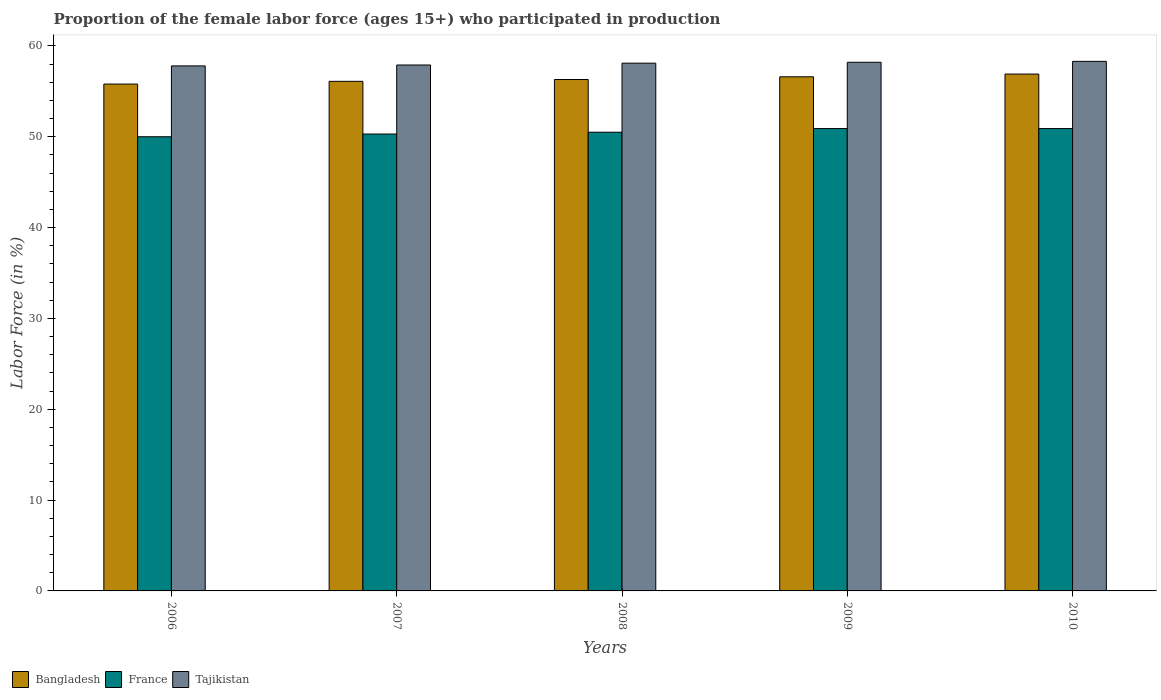How many different coloured bars are there?
Ensure brevity in your answer.  3. Are the number of bars per tick equal to the number of legend labels?
Give a very brief answer. Yes. Are the number of bars on each tick of the X-axis equal?
Your answer should be compact. Yes. How many bars are there on the 5th tick from the left?
Provide a short and direct response. 3. How many bars are there on the 5th tick from the right?
Keep it short and to the point. 3. What is the proportion of the female labor force who participated in production in France in 2009?
Provide a succinct answer. 50.9. Across all years, what is the maximum proportion of the female labor force who participated in production in Bangladesh?
Your response must be concise. 56.9. Across all years, what is the minimum proportion of the female labor force who participated in production in France?
Your answer should be very brief. 50. What is the total proportion of the female labor force who participated in production in Tajikistan in the graph?
Provide a succinct answer. 290.3. What is the difference between the proportion of the female labor force who participated in production in Tajikistan in 2006 and that in 2007?
Provide a short and direct response. -0.1. What is the difference between the proportion of the female labor force who participated in production in France in 2007 and the proportion of the female labor force who participated in production in Bangladesh in 2010?
Give a very brief answer. -6.6. What is the average proportion of the female labor force who participated in production in France per year?
Your answer should be very brief. 50.52. In the year 2007, what is the difference between the proportion of the female labor force who participated in production in France and proportion of the female labor force who participated in production in Bangladesh?
Offer a very short reply. -5.8. What is the ratio of the proportion of the female labor force who participated in production in Bangladesh in 2007 to that in 2008?
Your answer should be compact. 1. Is the difference between the proportion of the female labor force who participated in production in France in 2006 and 2008 greater than the difference between the proportion of the female labor force who participated in production in Bangladesh in 2006 and 2008?
Offer a very short reply. No. What is the difference between the highest and the lowest proportion of the female labor force who participated in production in France?
Your answer should be very brief. 0.9. In how many years, is the proportion of the female labor force who participated in production in France greater than the average proportion of the female labor force who participated in production in France taken over all years?
Offer a terse response. 2. What does the 1st bar from the right in 2008 represents?
Provide a short and direct response. Tajikistan. How many bars are there?
Keep it short and to the point. 15. How many years are there in the graph?
Keep it short and to the point. 5. What is the difference between two consecutive major ticks on the Y-axis?
Offer a very short reply. 10. Are the values on the major ticks of Y-axis written in scientific E-notation?
Offer a very short reply. No. Does the graph contain any zero values?
Keep it short and to the point. No. Where does the legend appear in the graph?
Offer a terse response. Bottom left. How are the legend labels stacked?
Provide a short and direct response. Horizontal. What is the title of the graph?
Make the answer very short. Proportion of the female labor force (ages 15+) who participated in production. What is the label or title of the X-axis?
Keep it short and to the point. Years. What is the Labor Force (in %) in Bangladesh in 2006?
Provide a succinct answer. 55.8. What is the Labor Force (in %) of Tajikistan in 2006?
Give a very brief answer. 57.8. What is the Labor Force (in %) in Bangladesh in 2007?
Ensure brevity in your answer.  56.1. What is the Labor Force (in %) in France in 2007?
Give a very brief answer. 50.3. What is the Labor Force (in %) of Tajikistan in 2007?
Your answer should be compact. 57.9. What is the Labor Force (in %) of Bangladesh in 2008?
Make the answer very short. 56.3. What is the Labor Force (in %) of France in 2008?
Offer a very short reply. 50.5. What is the Labor Force (in %) of Tajikistan in 2008?
Your answer should be compact. 58.1. What is the Labor Force (in %) in Bangladesh in 2009?
Offer a terse response. 56.6. What is the Labor Force (in %) of France in 2009?
Your answer should be very brief. 50.9. What is the Labor Force (in %) in Tajikistan in 2009?
Your answer should be compact. 58.2. What is the Labor Force (in %) in Bangladesh in 2010?
Your answer should be compact. 56.9. What is the Labor Force (in %) in France in 2010?
Keep it short and to the point. 50.9. What is the Labor Force (in %) of Tajikistan in 2010?
Ensure brevity in your answer.  58.3. Across all years, what is the maximum Labor Force (in %) of Bangladesh?
Offer a very short reply. 56.9. Across all years, what is the maximum Labor Force (in %) of France?
Keep it short and to the point. 50.9. Across all years, what is the maximum Labor Force (in %) of Tajikistan?
Your response must be concise. 58.3. Across all years, what is the minimum Labor Force (in %) of Bangladesh?
Keep it short and to the point. 55.8. Across all years, what is the minimum Labor Force (in %) in Tajikistan?
Your answer should be compact. 57.8. What is the total Labor Force (in %) of Bangladesh in the graph?
Offer a terse response. 281.7. What is the total Labor Force (in %) of France in the graph?
Your answer should be compact. 252.6. What is the total Labor Force (in %) in Tajikistan in the graph?
Ensure brevity in your answer.  290.3. What is the difference between the Labor Force (in %) of France in 2006 and that in 2008?
Keep it short and to the point. -0.5. What is the difference between the Labor Force (in %) in Tajikistan in 2006 and that in 2010?
Make the answer very short. -0.5. What is the difference between the Labor Force (in %) of Bangladesh in 2007 and that in 2008?
Offer a terse response. -0.2. What is the difference between the Labor Force (in %) of Tajikistan in 2007 and that in 2008?
Offer a very short reply. -0.2. What is the difference between the Labor Force (in %) of Bangladesh in 2007 and that in 2009?
Give a very brief answer. -0.5. What is the difference between the Labor Force (in %) of France in 2007 and that in 2009?
Provide a short and direct response. -0.6. What is the difference between the Labor Force (in %) in Bangladesh in 2007 and that in 2010?
Ensure brevity in your answer.  -0.8. What is the difference between the Labor Force (in %) of France in 2008 and that in 2009?
Offer a terse response. -0.4. What is the difference between the Labor Force (in %) of France in 2008 and that in 2010?
Offer a very short reply. -0.4. What is the difference between the Labor Force (in %) of France in 2009 and that in 2010?
Provide a succinct answer. 0. What is the difference between the Labor Force (in %) in Bangladesh in 2006 and the Labor Force (in %) in France in 2007?
Provide a short and direct response. 5.5. What is the difference between the Labor Force (in %) in Bangladesh in 2006 and the Labor Force (in %) in Tajikistan in 2007?
Provide a succinct answer. -2.1. What is the difference between the Labor Force (in %) in France in 2006 and the Labor Force (in %) in Tajikistan in 2007?
Your answer should be compact. -7.9. What is the difference between the Labor Force (in %) in Bangladesh in 2006 and the Labor Force (in %) in Tajikistan in 2008?
Provide a succinct answer. -2.3. What is the difference between the Labor Force (in %) in Bangladesh in 2006 and the Labor Force (in %) in France in 2009?
Make the answer very short. 4.9. What is the difference between the Labor Force (in %) of Bangladesh in 2006 and the Labor Force (in %) of Tajikistan in 2009?
Offer a very short reply. -2.4. What is the difference between the Labor Force (in %) in France in 2006 and the Labor Force (in %) in Tajikistan in 2009?
Give a very brief answer. -8.2. What is the difference between the Labor Force (in %) in Bangladesh in 2006 and the Labor Force (in %) in France in 2010?
Your answer should be very brief. 4.9. What is the difference between the Labor Force (in %) in Bangladesh in 2007 and the Labor Force (in %) in France in 2008?
Your answer should be very brief. 5.6. What is the difference between the Labor Force (in %) in Bangladesh in 2007 and the Labor Force (in %) in Tajikistan in 2009?
Your response must be concise. -2.1. What is the difference between the Labor Force (in %) of France in 2007 and the Labor Force (in %) of Tajikistan in 2009?
Your response must be concise. -7.9. What is the difference between the Labor Force (in %) of Bangladesh in 2007 and the Labor Force (in %) of Tajikistan in 2010?
Provide a short and direct response. -2.2. What is the difference between the Labor Force (in %) of France in 2008 and the Labor Force (in %) of Tajikistan in 2009?
Give a very brief answer. -7.7. What is the difference between the Labor Force (in %) in France in 2008 and the Labor Force (in %) in Tajikistan in 2010?
Ensure brevity in your answer.  -7.8. What is the difference between the Labor Force (in %) in Bangladesh in 2009 and the Labor Force (in %) in Tajikistan in 2010?
Make the answer very short. -1.7. What is the difference between the Labor Force (in %) of France in 2009 and the Labor Force (in %) of Tajikistan in 2010?
Provide a succinct answer. -7.4. What is the average Labor Force (in %) of Bangladesh per year?
Your response must be concise. 56.34. What is the average Labor Force (in %) in France per year?
Keep it short and to the point. 50.52. What is the average Labor Force (in %) of Tajikistan per year?
Make the answer very short. 58.06. In the year 2006, what is the difference between the Labor Force (in %) in Bangladesh and Labor Force (in %) in France?
Your answer should be compact. 5.8. In the year 2007, what is the difference between the Labor Force (in %) of France and Labor Force (in %) of Tajikistan?
Your answer should be very brief. -7.6. In the year 2008, what is the difference between the Labor Force (in %) of Bangladesh and Labor Force (in %) of Tajikistan?
Give a very brief answer. -1.8. In the year 2008, what is the difference between the Labor Force (in %) in France and Labor Force (in %) in Tajikistan?
Your answer should be compact. -7.6. In the year 2009, what is the difference between the Labor Force (in %) in Bangladesh and Labor Force (in %) in France?
Your answer should be compact. 5.7. In the year 2009, what is the difference between the Labor Force (in %) in Bangladesh and Labor Force (in %) in Tajikistan?
Your answer should be compact. -1.6. What is the ratio of the Labor Force (in %) in Bangladesh in 2006 to that in 2007?
Offer a terse response. 0.99. What is the ratio of the Labor Force (in %) of France in 2006 to that in 2007?
Make the answer very short. 0.99. What is the ratio of the Labor Force (in %) in Tajikistan in 2006 to that in 2007?
Offer a very short reply. 1. What is the ratio of the Labor Force (in %) in Bangladesh in 2006 to that in 2008?
Your answer should be very brief. 0.99. What is the ratio of the Labor Force (in %) in France in 2006 to that in 2008?
Your response must be concise. 0.99. What is the ratio of the Labor Force (in %) in Bangladesh in 2006 to that in 2009?
Offer a very short reply. 0.99. What is the ratio of the Labor Force (in %) in France in 2006 to that in 2009?
Your answer should be compact. 0.98. What is the ratio of the Labor Force (in %) in Tajikistan in 2006 to that in 2009?
Ensure brevity in your answer.  0.99. What is the ratio of the Labor Force (in %) in Bangladesh in 2006 to that in 2010?
Offer a terse response. 0.98. What is the ratio of the Labor Force (in %) of France in 2006 to that in 2010?
Make the answer very short. 0.98. What is the ratio of the Labor Force (in %) of Bangladesh in 2007 to that in 2008?
Your answer should be compact. 1. What is the ratio of the Labor Force (in %) of France in 2007 to that in 2009?
Your response must be concise. 0.99. What is the ratio of the Labor Force (in %) in Tajikistan in 2007 to that in 2009?
Your response must be concise. 0.99. What is the ratio of the Labor Force (in %) in Bangladesh in 2007 to that in 2010?
Keep it short and to the point. 0.99. What is the ratio of the Labor Force (in %) of Bangladesh in 2008 to that in 2009?
Offer a terse response. 0.99. What is the ratio of the Labor Force (in %) in Bangladesh in 2008 to that in 2010?
Your answer should be very brief. 0.99. What is the ratio of the Labor Force (in %) in France in 2009 to that in 2010?
Keep it short and to the point. 1. What is the difference between the highest and the second highest Labor Force (in %) in France?
Provide a succinct answer. 0. What is the difference between the highest and the second highest Labor Force (in %) of Tajikistan?
Your answer should be very brief. 0.1. What is the difference between the highest and the lowest Labor Force (in %) in Bangladesh?
Give a very brief answer. 1.1. What is the difference between the highest and the lowest Labor Force (in %) in France?
Offer a terse response. 0.9. What is the difference between the highest and the lowest Labor Force (in %) of Tajikistan?
Provide a short and direct response. 0.5. 